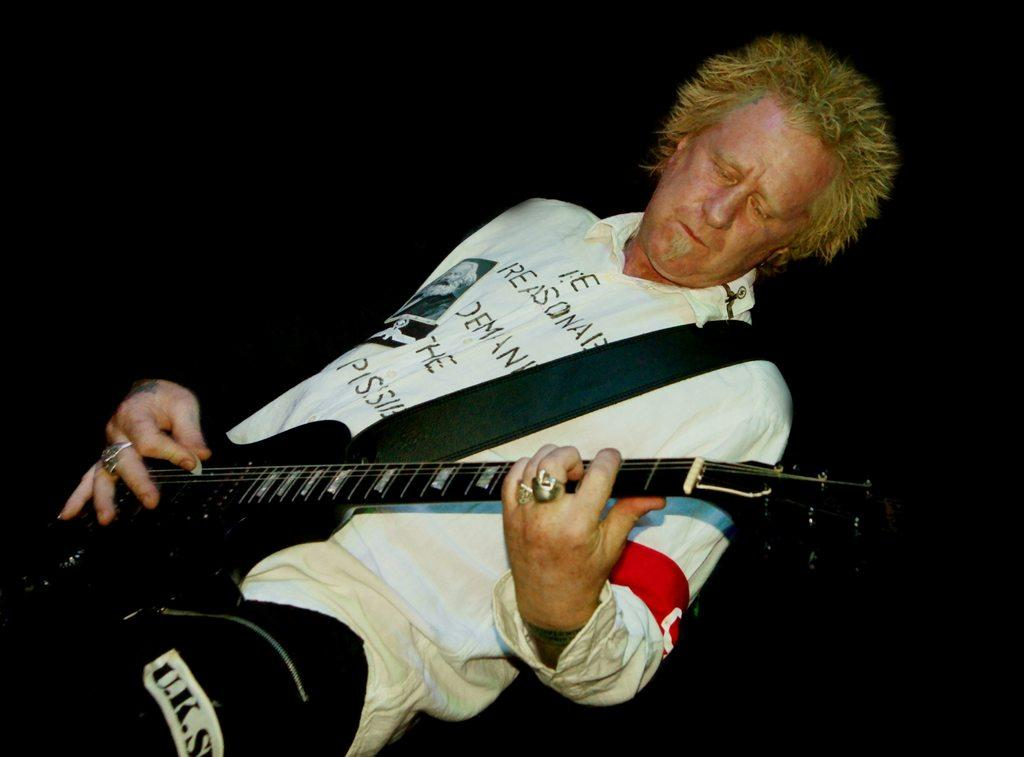Who is the main subject in the image? There is a man in the image. What is the man doing in the image? The man is standing and playing a guitar. What can be observed about the background of the image? The background of the image is dark. What type of print can be seen on the man's shirt in the image? There is no print visible on the man's shirt in the image. Are there any clams present in the image? There are no clams present in the image. 